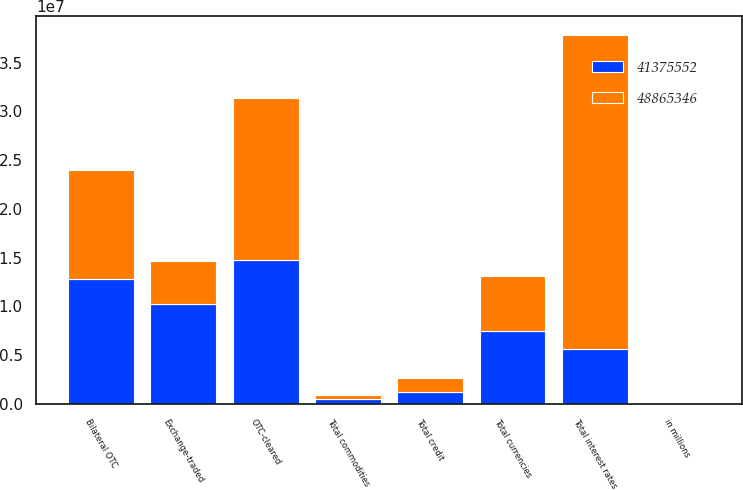Convert chart to OTSL. <chart><loc_0><loc_0><loc_500><loc_500><stacked_bar_chart><ecel><fcel>in millions<fcel>Exchange-traded<fcel>OTC-cleared<fcel>Bilateral OTC<fcel>Total interest rates<fcel>Total credit<fcel>Total currencies<fcel>Total commodities<nl><fcel>4.13756e+07<fcel>2017<fcel>1.02125e+07<fcel>1.47396e+07<fcel>1.28623e+07<fcel>5.65335e+06<fcel>1.25439e+06<fcel>7.44052e+06<fcel>494221<nl><fcel>4.88653e+07<fcel>2016<fcel>4.42553e+06<fcel>1.66461e+07<fcel>1.11314e+07<fcel>3.22031e+07<fcel>1.42434e+06<fcel>5.65335e+06<fcel>428112<nl></chart> 